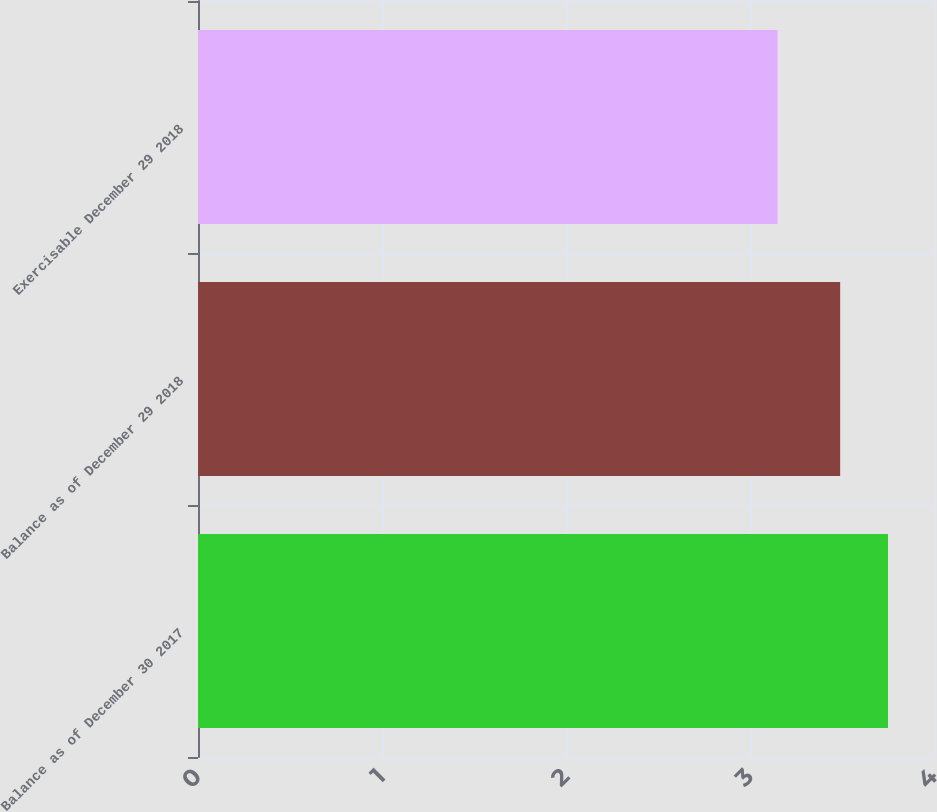Convert chart. <chart><loc_0><loc_0><loc_500><loc_500><bar_chart><fcel>Balance as of December 30 2017<fcel>Balance as of December 29 2018<fcel>Exercisable December 29 2018<nl><fcel>3.75<fcel>3.49<fcel>3.15<nl></chart> 